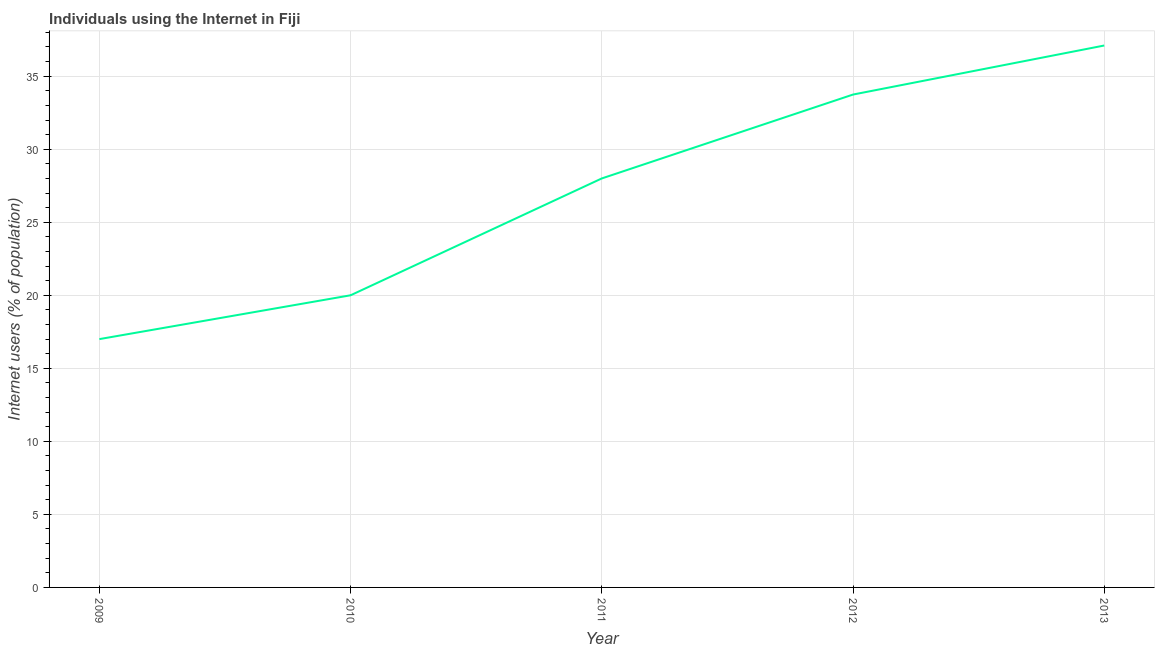Across all years, what is the maximum number of internet users?
Offer a terse response. 37.1. In which year was the number of internet users maximum?
Your answer should be compact. 2013. In which year was the number of internet users minimum?
Your answer should be compact. 2009. What is the sum of the number of internet users?
Your response must be concise. 135.84. What is the difference between the number of internet users in 2011 and 2012?
Provide a succinct answer. -5.74. What is the average number of internet users per year?
Offer a very short reply. 27.17. In how many years, is the number of internet users greater than 2 %?
Your answer should be compact. 5. Do a majority of the years between 2011 and 2012 (inclusive) have number of internet users greater than 6 %?
Make the answer very short. Yes. What is the ratio of the number of internet users in 2011 to that in 2012?
Your response must be concise. 0.83. Is the number of internet users in 2011 less than that in 2012?
Give a very brief answer. Yes. What is the difference between the highest and the second highest number of internet users?
Your response must be concise. 3.36. What is the difference between the highest and the lowest number of internet users?
Keep it short and to the point. 20.1. Does the number of internet users monotonically increase over the years?
Offer a terse response. Yes. How many lines are there?
Ensure brevity in your answer.  1. How many years are there in the graph?
Your answer should be very brief. 5. What is the difference between two consecutive major ticks on the Y-axis?
Make the answer very short. 5. What is the title of the graph?
Give a very brief answer. Individuals using the Internet in Fiji. What is the label or title of the X-axis?
Your answer should be very brief. Year. What is the label or title of the Y-axis?
Offer a very short reply. Internet users (% of population). What is the Internet users (% of population) of 2009?
Keep it short and to the point. 17. What is the Internet users (% of population) in 2011?
Ensure brevity in your answer.  28. What is the Internet users (% of population) of 2012?
Ensure brevity in your answer.  33.74. What is the Internet users (% of population) in 2013?
Provide a short and direct response. 37.1. What is the difference between the Internet users (% of population) in 2009 and 2012?
Ensure brevity in your answer.  -16.74. What is the difference between the Internet users (% of population) in 2009 and 2013?
Provide a short and direct response. -20.1. What is the difference between the Internet users (% of population) in 2010 and 2012?
Ensure brevity in your answer.  -13.74. What is the difference between the Internet users (% of population) in 2010 and 2013?
Offer a terse response. -17.1. What is the difference between the Internet users (% of population) in 2011 and 2012?
Provide a short and direct response. -5.74. What is the difference between the Internet users (% of population) in 2011 and 2013?
Keep it short and to the point. -9.1. What is the difference between the Internet users (% of population) in 2012 and 2013?
Your response must be concise. -3.36. What is the ratio of the Internet users (% of population) in 2009 to that in 2010?
Your response must be concise. 0.85. What is the ratio of the Internet users (% of population) in 2009 to that in 2011?
Provide a short and direct response. 0.61. What is the ratio of the Internet users (% of population) in 2009 to that in 2012?
Offer a very short reply. 0.5. What is the ratio of the Internet users (% of population) in 2009 to that in 2013?
Provide a short and direct response. 0.46. What is the ratio of the Internet users (% of population) in 2010 to that in 2011?
Make the answer very short. 0.71. What is the ratio of the Internet users (% of population) in 2010 to that in 2012?
Offer a very short reply. 0.59. What is the ratio of the Internet users (% of population) in 2010 to that in 2013?
Offer a very short reply. 0.54. What is the ratio of the Internet users (% of population) in 2011 to that in 2012?
Offer a terse response. 0.83. What is the ratio of the Internet users (% of population) in 2011 to that in 2013?
Offer a terse response. 0.76. What is the ratio of the Internet users (% of population) in 2012 to that in 2013?
Ensure brevity in your answer.  0.91. 